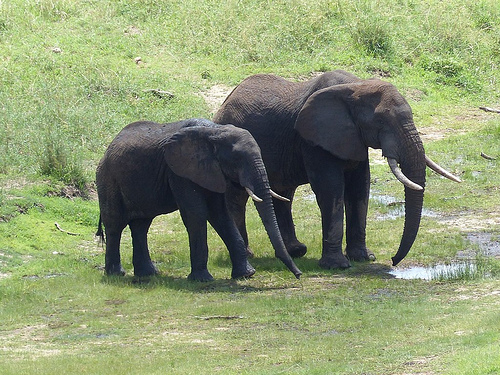What is the size of the elephant that the hill is behind of? The elephant that the hill is behind of is large in size. 